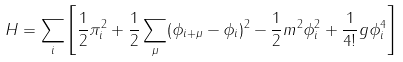<formula> <loc_0><loc_0><loc_500><loc_500>H = \sum _ { i } \left [ \frac { 1 } { 2 } \pi _ { i } ^ { 2 } + \frac { 1 } { 2 } \sum _ { \mu } ( \phi _ { i + \mu } - \phi _ { i } ) ^ { 2 } - \frac { 1 } { 2 } m ^ { 2 } \phi _ { i } ^ { 2 } + \frac { 1 } { 4 ! } g \phi _ { i } ^ { 4 } \right ]</formula> 